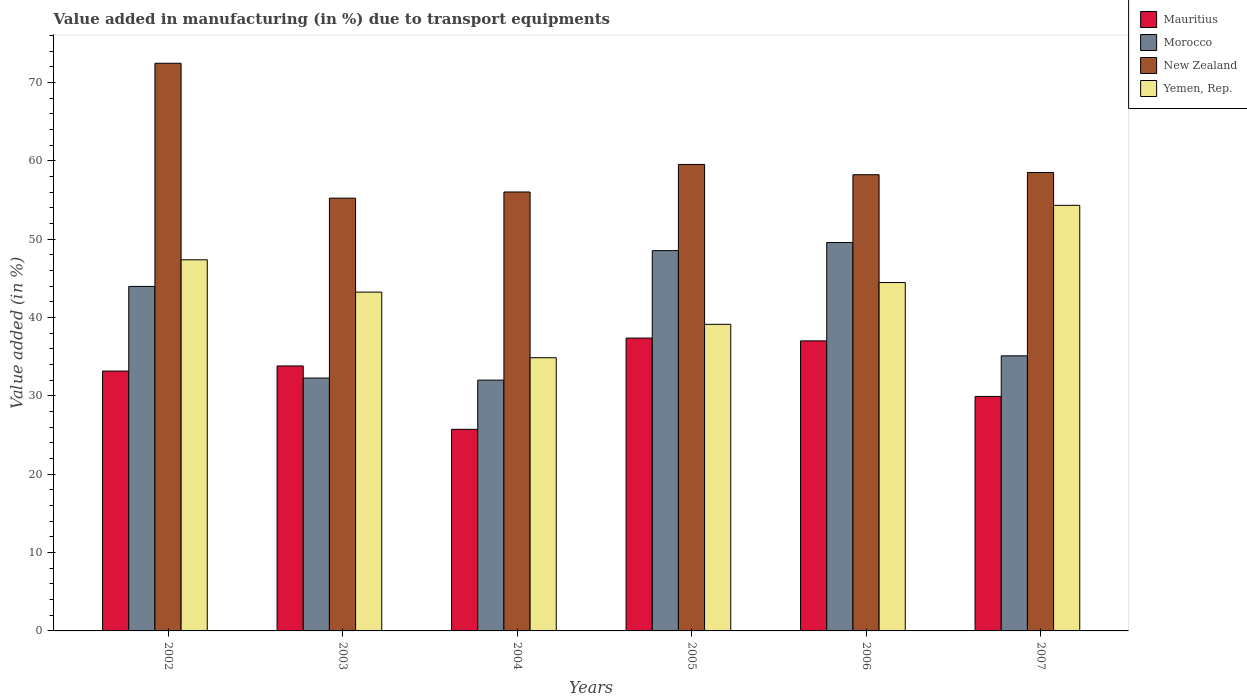How many groups of bars are there?
Your answer should be compact. 6. Are the number of bars on each tick of the X-axis equal?
Your answer should be compact. Yes. How many bars are there on the 4th tick from the left?
Keep it short and to the point. 4. In how many cases, is the number of bars for a given year not equal to the number of legend labels?
Provide a succinct answer. 0. What is the percentage of value added in manufacturing due to transport equipments in Yemen, Rep. in 2002?
Keep it short and to the point. 47.36. Across all years, what is the maximum percentage of value added in manufacturing due to transport equipments in New Zealand?
Keep it short and to the point. 72.45. Across all years, what is the minimum percentage of value added in manufacturing due to transport equipments in Morocco?
Keep it short and to the point. 32.01. In which year was the percentage of value added in manufacturing due to transport equipments in Mauritius maximum?
Provide a succinct answer. 2005. In which year was the percentage of value added in manufacturing due to transport equipments in New Zealand minimum?
Ensure brevity in your answer.  2003. What is the total percentage of value added in manufacturing due to transport equipments in New Zealand in the graph?
Provide a short and direct response. 359.95. What is the difference between the percentage of value added in manufacturing due to transport equipments in Yemen, Rep. in 2003 and that in 2004?
Offer a very short reply. 8.37. What is the difference between the percentage of value added in manufacturing due to transport equipments in Morocco in 2005 and the percentage of value added in manufacturing due to transport equipments in Yemen, Rep. in 2006?
Give a very brief answer. 4.07. What is the average percentage of value added in manufacturing due to transport equipments in Morocco per year?
Keep it short and to the point. 40.24. In the year 2006, what is the difference between the percentage of value added in manufacturing due to transport equipments in Mauritius and percentage of value added in manufacturing due to transport equipments in Morocco?
Your answer should be very brief. -12.55. In how many years, is the percentage of value added in manufacturing due to transport equipments in Yemen, Rep. greater than 6 %?
Your answer should be very brief. 6. What is the ratio of the percentage of value added in manufacturing due to transport equipments in New Zealand in 2003 to that in 2006?
Offer a terse response. 0.95. Is the difference between the percentage of value added in manufacturing due to transport equipments in Mauritius in 2002 and 2004 greater than the difference between the percentage of value added in manufacturing due to transport equipments in Morocco in 2002 and 2004?
Ensure brevity in your answer.  No. What is the difference between the highest and the second highest percentage of value added in manufacturing due to transport equipments in Mauritius?
Give a very brief answer. 0.36. What is the difference between the highest and the lowest percentage of value added in manufacturing due to transport equipments in Mauritius?
Offer a very short reply. 11.64. Is the sum of the percentage of value added in manufacturing due to transport equipments in Morocco in 2002 and 2006 greater than the maximum percentage of value added in manufacturing due to transport equipments in Mauritius across all years?
Provide a succinct answer. Yes. Is it the case that in every year, the sum of the percentage of value added in manufacturing due to transport equipments in Morocco and percentage of value added in manufacturing due to transport equipments in Mauritius is greater than the sum of percentage of value added in manufacturing due to transport equipments in Yemen, Rep. and percentage of value added in manufacturing due to transport equipments in New Zealand?
Provide a succinct answer. No. What does the 1st bar from the left in 2003 represents?
Offer a very short reply. Mauritius. What does the 3rd bar from the right in 2007 represents?
Give a very brief answer. Morocco. How many bars are there?
Your answer should be compact. 24. What is the difference between two consecutive major ticks on the Y-axis?
Provide a short and direct response. 10. Are the values on the major ticks of Y-axis written in scientific E-notation?
Keep it short and to the point. No. Does the graph contain grids?
Provide a short and direct response. No. Where does the legend appear in the graph?
Give a very brief answer. Top right. How many legend labels are there?
Keep it short and to the point. 4. What is the title of the graph?
Ensure brevity in your answer.  Value added in manufacturing (in %) due to transport equipments. Does "American Samoa" appear as one of the legend labels in the graph?
Keep it short and to the point. No. What is the label or title of the Y-axis?
Offer a terse response. Value added (in %). What is the Value added (in %) of Mauritius in 2002?
Give a very brief answer. 33.16. What is the Value added (in %) of Morocco in 2002?
Your answer should be compact. 43.97. What is the Value added (in %) of New Zealand in 2002?
Provide a short and direct response. 72.45. What is the Value added (in %) in Yemen, Rep. in 2002?
Make the answer very short. 47.36. What is the Value added (in %) in Mauritius in 2003?
Offer a very short reply. 33.81. What is the Value added (in %) in Morocco in 2003?
Offer a terse response. 32.27. What is the Value added (in %) of New Zealand in 2003?
Provide a succinct answer. 55.23. What is the Value added (in %) in Yemen, Rep. in 2003?
Make the answer very short. 43.24. What is the Value added (in %) of Mauritius in 2004?
Give a very brief answer. 25.73. What is the Value added (in %) of Morocco in 2004?
Provide a succinct answer. 32.01. What is the Value added (in %) in New Zealand in 2004?
Ensure brevity in your answer.  56.02. What is the Value added (in %) in Yemen, Rep. in 2004?
Keep it short and to the point. 34.86. What is the Value added (in %) of Mauritius in 2005?
Make the answer very short. 37.37. What is the Value added (in %) of Morocco in 2005?
Provide a short and direct response. 48.53. What is the Value added (in %) in New Zealand in 2005?
Your response must be concise. 59.53. What is the Value added (in %) of Yemen, Rep. in 2005?
Your answer should be very brief. 39.13. What is the Value added (in %) in Mauritius in 2006?
Your answer should be very brief. 37.02. What is the Value added (in %) of Morocco in 2006?
Provide a succinct answer. 49.57. What is the Value added (in %) of New Zealand in 2006?
Your response must be concise. 58.22. What is the Value added (in %) of Yemen, Rep. in 2006?
Your response must be concise. 44.46. What is the Value added (in %) of Mauritius in 2007?
Provide a succinct answer. 29.93. What is the Value added (in %) of Morocco in 2007?
Make the answer very short. 35.11. What is the Value added (in %) of New Zealand in 2007?
Keep it short and to the point. 58.5. What is the Value added (in %) of Yemen, Rep. in 2007?
Make the answer very short. 54.32. Across all years, what is the maximum Value added (in %) of Mauritius?
Offer a very short reply. 37.37. Across all years, what is the maximum Value added (in %) of Morocco?
Provide a succinct answer. 49.57. Across all years, what is the maximum Value added (in %) of New Zealand?
Offer a terse response. 72.45. Across all years, what is the maximum Value added (in %) of Yemen, Rep.?
Make the answer very short. 54.32. Across all years, what is the minimum Value added (in %) in Mauritius?
Provide a short and direct response. 25.73. Across all years, what is the minimum Value added (in %) in Morocco?
Make the answer very short. 32.01. Across all years, what is the minimum Value added (in %) in New Zealand?
Ensure brevity in your answer.  55.23. Across all years, what is the minimum Value added (in %) in Yemen, Rep.?
Provide a short and direct response. 34.86. What is the total Value added (in %) in Mauritius in the graph?
Give a very brief answer. 197.02. What is the total Value added (in %) in Morocco in the graph?
Ensure brevity in your answer.  241.45. What is the total Value added (in %) of New Zealand in the graph?
Make the answer very short. 359.95. What is the total Value added (in %) in Yemen, Rep. in the graph?
Your answer should be very brief. 263.37. What is the difference between the Value added (in %) of Mauritius in 2002 and that in 2003?
Provide a succinct answer. -0.65. What is the difference between the Value added (in %) in Morocco in 2002 and that in 2003?
Make the answer very short. 11.7. What is the difference between the Value added (in %) of New Zealand in 2002 and that in 2003?
Your answer should be compact. 17.21. What is the difference between the Value added (in %) of Yemen, Rep. in 2002 and that in 2003?
Ensure brevity in your answer.  4.12. What is the difference between the Value added (in %) in Mauritius in 2002 and that in 2004?
Give a very brief answer. 7.43. What is the difference between the Value added (in %) in Morocco in 2002 and that in 2004?
Your answer should be compact. 11.96. What is the difference between the Value added (in %) in New Zealand in 2002 and that in 2004?
Offer a very short reply. 16.43. What is the difference between the Value added (in %) of Yemen, Rep. in 2002 and that in 2004?
Ensure brevity in your answer.  12.5. What is the difference between the Value added (in %) of Mauritius in 2002 and that in 2005?
Your answer should be very brief. -4.21. What is the difference between the Value added (in %) in Morocco in 2002 and that in 2005?
Offer a very short reply. -4.57. What is the difference between the Value added (in %) in New Zealand in 2002 and that in 2005?
Ensure brevity in your answer.  12.91. What is the difference between the Value added (in %) in Yemen, Rep. in 2002 and that in 2005?
Offer a very short reply. 8.24. What is the difference between the Value added (in %) of Mauritius in 2002 and that in 2006?
Offer a terse response. -3.85. What is the difference between the Value added (in %) in Morocco in 2002 and that in 2006?
Offer a very short reply. -5.6. What is the difference between the Value added (in %) of New Zealand in 2002 and that in 2006?
Offer a terse response. 14.22. What is the difference between the Value added (in %) of Yemen, Rep. in 2002 and that in 2006?
Your response must be concise. 2.9. What is the difference between the Value added (in %) in Mauritius in 2002 and that in 2007?
Provide a succinct answer. 3.24. What is the difference between the Value added (in %) of Morocco in 2002 and that in 2007?
Your answer should be very brief. 8.86. What is the difference between the Value added (in %) of New Zealand in 2002 and that in 2007?
Offer a very short reply. 13.94. What is the difference between the Value added (in %) of Yemen, Rep. in 2002 and that in 2007?
Offer a terse response. -6.95. What is the difference between the Value added (in %) in Mauritius in 2003 and that in 2004?
Provide a succinct answer. 8.09. What is the difference between the Value added (in %) of Morocco in 2003 and that in 2004?
Keep it short and to the point. 0.26. What is the difference between the Value added (in %) in New Zealand in 2003 and that in 2004?
Make the answer very short. -0.79. What is the difference between the Value added (in %) in Yemen, Rep. in 2003 and that in 2004?
Your response must be concise. 8.37. What is the difference between the Value added (in %) in Mauritius in 2003 and that in 2005?
Your answer should be compact. -3.56. What is the difference between the Value added (in %) in Morocco in 2003 and that in 2005?
Provide a succinct answer. -16.26. What is the difference between the Value added (in %) of New Zealand in 2003 and that in 2005?
Make the answer very short. -4.3. What is the difference between the Value added (in %) in Yemen, Rep. in 2003 and that in 2005?
Ensure brevity in your answer.  4.11. What is the difference between the Value added (in %) in Mauritius in 2003 and that in 2006?
Provide a succinct answer. -3.2. What is the difference between the Value added (in %) of Morocco in 2003 and that in 2006?
Provide a succinct answer. -17.29. What is the difference between the Value added (in %) of New Zealand in 2003 and that in 2006?
Your response must be concise. -2.99. What is the difference between the Value added (in %) of Yemen, Rep. in 2003 and that in 2006?
Offer a terse response. -1.22. What is the difference between the Value added (in %) in Mauritius in 2003 and that in 2007?
Offer a terse response. 3.89. What is the difference between the Value added (in %) in Morocco in 2003 and that in 2007?
Your response must be concise. -2.83. What is the difference between the Value added (in %) of New Zealand in 2003 and that in 2007?
Make the answer very short. -3.27. What is the difference between the Value added (in %) of Yemen, Rep. in 2003 and that in 2007?
Make the answer very short. -11.08. What is the difference between the Value added (in %) of Mauritius in 2004 and that in 2005?
Provide a short and direct response. -11.64. What is the difference between the Value added (in %) of Morocco in 2004 and that in 2005?
Give a very brief answer. -16.52. What is the difference between the Value added (in %) in New Zealand in 2004 and that in 2005?
Provide a succinct answer. -3.52. What is the difference between the Value added (in %) of Yemen, Rep. in 2004 and that in 2005?
Your answer should be compact. -4.26. What is the difference between the Value added (in %) in Mauritius in 2004 and that in 2006?
Your response must be concise. -11.29. What is the difference between the Value added (in %) in Morocco in 2004 and that in 2006?
Provide a succinct answer. -17.56. What is the difference between the Value added (in %) in New Zealand in 2004 and that in 2006?
Give a very brief answer. -2.2. What is the difference between the Value added (in %) of Yemen, Rep. in 2004 and that in 2006?
Offer a very short reply. -9.6. What is the difference between the Value added (in %) of Mauritius in 2004 and that in 2007?
Ensure brevity in your answer.  -4.2. What is the difference between the Value added (in %) in Morocco in 2004 and that in 2007?
Your response must be concise. -3.1. What is the difference between the Value added (in %) in New Zealand in 2004 and that in 2007?
Give a very brief answer. -2.49. What is the difference between the Value added (in %) of Yemen, Rep. in 2004 and that in 2007?
Provide a short and direct response. -19.45. What is the difference between the Value added (in %) of Mauritius in 2005 and that in 2006?
Your response must be concise. 0.36. What is the difference between the Value added (in %) in Morocco in 2005 and that in 2006?
Your response must be concise. -1.03. What is the difference between the Value added (in %) in New Zealand in 2005 and that in 2006?
Ensure brevity in your answer.  1.31. What is the difference between the Value added (in %) of Yemen, Rep. in 2005 and that in 2006?
Give a very brief answer. -5.33. What is the difference between the Value added (in %) in Mauritius in 2005 and that in 2007?
Give a very brief answer. 7.44. What is the difference between the Value added (in %) of Morocco in 2005 and that in 2007?
Make the answer very short. 13.43. What is the difference between the Value added (in %) of New Zealand in 2005 and that in 2007?
Keep it short and to the point. 1.03. What is the difference between the Value added (in %) in Yemen, Rep. in 2005 and that in 2007?
Your answer should be compact. -15.19. What is the difference between the Value added (in %) in Mauritius in 2006 and that in 2007?
Make the answer very short. 7.09. What is the difference between the Value added (in %) in Morocco in 2006 and that in 2007?
Offer a very short reply. 14.46. What is the difference between the Value added (in %) of New Zealand in 2006 and that in 2007?
Provide a short and direct response. -0.28. What is the difference between the Value added (in %) in Yemen, Rep. in 2006 and that in 2007?
Offer a terse response. -9.86. What is the difference between the Value added (in %) in Mauritius in 2002 and the Value added (in %) in Morocco in 2003?
Give a very brief answer. 0.89. What is the difference between the Value added (in %) in Mauritius in 2002 and the Value added (in %) in New Zealand in 2003?
Your response must be concise. -22.07. What is the difference between the Value added (in %) of Mauritius in 2002 and the Value added (in %) of Yemen, Rep. in 2003?
Offer a very short reply. -10.07. What is the difference between the Value added (in %) in Morocco in 2002 and the Value added (in %) in New Zealand in 2003?
Offer a terse response. -11.26. What is the difference between the Value added (in %) in Morocco in 2002 and the Value added (in %) in Yemen, Rep. in 2003?
Keep it short and to the point. 0.73. What is the difference between the Value added (in %) of New Zealand in 2002 and the Value added (in %) of Yemen, Rep. in 2003?
Provide a short and direct response. 29.21. What is the difference between the Value added (in %) of Mauritius in 2002 and the Value added (in %) of Morocco in 2004?
Your response must be concise. 1.16. What is the difference between the Value added (in %) of Mauritius in 2002 and the Value added (in %) of New Zealand in 2004?
Your response must be concise. -22.85. What is the difference between the Value added (in %) in Mauritius in 2002 and the Value added (in %) in Yemen, Rep. in 2004?
Make the answer very short. -1.7. What is the difference between the Value added (in %) in Morocco in 2002 and the Value added (in %) in New Zealand in 2004?
Keep it short and to the point. -12.05. What is the difference between the Value added (in %) of Morocco in 2002 and the Value added (in %) of Yemen, Rep. in 2004?
Give a very brief answer. 9.1. What is the difference between the Value added (in %) in New Zealand in 2002 and the Value added (in %) in Yemen, Rep. in 2004?
Offer a terse response. 37.58. What is the difference between the Value added (in %) in Mauritius in 2002 and the Value added (in %) in Morocco in 2005?
Offer a very short reply. -15.37. What is the difference between the Value added (in %) of Mauritius in 2002 and the Value added (in %) of New Zealand in 2005?
Offer a terse response. -26.37. What is the difference between the Value added (in %) of Mauritius in 2002 and the Value added (in %) of Yemen, Rep. in 2005?
Your answer should be compact. -5.96. What is the difference between the Value added (in %) in Morocco in 2002 and the Value added (in %) in New Zealand in 2005?
Provide a short and direct response. -15.57. What is the difference between the Value added (in %) of Morocco in 2002 and the Value added (in %) of Yemen, Rep. in 2005?
Your response must be concise. 4.84. What is the difference between the Value added (in %) of New Zealand in 2002 and the Value added (in %) of Yemen, Rep. in 2005?
Keep it short and to the point. 33.32. What is the difference between the Value added (in %) of Mauritius in 2002 and the Value added (in %) of Morocco in 2006?
Give a very brief answer. -16.4. What is the difference between the Value added (in %) in Mauritius in 2002 and the Value added (in %) in New Zealand in 2006?
Ensure brevity in your answer.  -25.06. What is the difference between the Value added (in %) in Mauritius in 2002 and the Value added (in %) in Yemen, Rep. in 2006?
Make the answer very short. -11.3. What is the difference between the Value added (in %) of Morocco in 2002 and the Value added (in %) of New Zealand in 2006?
Ensure brevity in your answer.  -14.25. What is the difference between the Value added (in %) of Morocco in 2002 and the Value added (in %) of Yemen, Rep. in 2006?
Offer a terse response. -0.49. What is the difference between the Value added (in %) of New Zealand in 2002 and the Value added (in %) of Yemen, Rep. in 2006?
Make the answer very short. 27.98. What is the difference between the Value added (in %) in Mauritius in 2002 and the Value added (in %) in Morocco in 2007?
Your answer should be compact. -1.94. What is the difference between the Value added (in %) in Mauritius in 2002 and the Value added (in %) in New Zealand in 2007?
Offer a very short reply. -25.34. What is the difference between the Value added (in %) in Mauritius in 2002 and the Value added (in %) in Yemen, Rep. in 2007?
Provide a short and direct response. -21.15. What is the difference between the Value added (in %) in Morocco in 2002 and the Value added (in %) in New Zealand in 2007?
Offer a very short reply. -14.54. What is the difference between the Value added (in %) in Morocco in 2002 and the Value added (in %) in Yemen, Rep. in 2007?
Ensure brevity in your answer.  -10.35. What is the difference between the Value added (in %) in New Zealand in 2002 and the Value added (in %) in Yemen, Rep. in 2007?
Ensure brevity in your answer.  18.13. What is the difference between the Value added (in %) of Mauritius in 2003 and the Value added (in %) of Morocco in 2004?
Ensure brevity in your answer.  1.81. What is the difference between the Value added (in %) in Mauritius in 2003 and the Value added (in %) in New Zealand in 2004?
Offer a terse response. -22.2. What is the difference between the Value added (in %) of Mauritius in 2003 and the Value added (in %) of Yemen, Rep. in 2004?
Make the answer very short. -1.05. What is the difference between the Value added (in %) in Morocco in 2003 and the Value added (in %) in New Zealand in 2004?
Offer a very short reply. -23.75. What is the difference between the Value added (in %) in Morocco in 2003 and the Value added (in %) in Yemen, Rep. in 2004?
Your answer should be compact. -2.59. What is the difference between the Value added (in %) in New Zealand in 2003 and the Value added (in %) in Yemen, Rep. in 2004?
Your answer should be very brief. 20.37. What is the difference between the Value added (in %) in Mauritius in 2003 and the Value added (in %) in Morocco in 2005?
Your answer should be very brief. -14.72. What is the difference between the Value added (in %) of Mauritius in 2003 and the Value added (in %) of New Zealand in 2005?
Offer a terse response. -25.72. What is the difference between the Value added (in %) of Mauritius in 2003 and the Value added (in %) of Yemen, Rep. in 2005?
Your response must be concise. -5.31. What is the difference between the Value added (in %) of Morocco in 2003 and the Value added (in %) of New Zealand in 2005?
Ensure brevity in your answer.  -27.26. What is the difference between the Value added (in %) in Morocco in 2003 and the Value added (in %) in Yemen, Rep. in 2005?
Give a very brief answer. -6.86. What is the difference between the Value added (in %) in New Zealand in 2003 and the Value added (in %) in Yemen, Rep. in 2005?
Offer a very short reply. 16.1. What is the difference between the Value added (in %) of Mauritius in 2003 and the Value added (in %) of Morocco in 2006?
Offer a terse response. -15.75. What is the difference between the Value added (in %) of Mauritius in 2003 and the Value added (in %) of New Zealand in 2006?
Offer a very short reply. -24.41. What is the difference between the Value added (in %) in Mauritius in 2003 and the Value added (in %) in Yemen, Rep. in 2006?
Make the answer very short. -10.65. What is the difference between the Value added (in %) in Morocco in 2003 and the Value added (in %) in New Zealand in 2006?
Make the answer very short. -25.95. What is the difference between the Value added (in %) of Morocco in 2003 and the Value added (in %) of Yemen, Rep. in 2006?
Your answer should be compact. -12.19. What is the difference between the Value added (in %) of New Zealand in 2003 and the Value added (in %) of Yemen, Rep. in 2006?
Offer a terse response. 10.77. What is the difference between the Value added (in %) of Mauritius in 2003 and the Value added (in %) of Morocco in 2007?
Make the answer very short. -1.29. What is the difference between the Value added (in %) of Mauritius in 2003 and the Value added (in %) of New Zealand in 2007?
Make the answer very short. -24.69. What is the difference between the Value added (in %) in Mauritius in 2003 and the Value added (in %) in Yemen, Rep. in 2007?
Offer a terse response. -20.5. What is the difference between the Value added (in %) of Morocco in 2003 and the Value added (in %) of New Zealand in 2007?
Provide a succinct answer. -26.23. What is the difference between the Value added (in %) in Morocco in 2003 and the Value added (in %) in Yemen, Rep. in 2007?
Offer a very short reply. -22.04. What is the difference between the Value added (in %) in New Zealand in 2003 and the Value added (in %) in Yemen, Rep. in 2007?
Offer a very short reply. 0.92. What is the difference between the Value added (in %) of Mauritius in 2004 and the Value added (in %) of Morocco in 2005?
Ensure brevity in your answer.  -22.8. What is the difference between the Value added (in %) in Mauritius in 2004 and the Value added (in %) in New Zealand in 2005?
Ensure brevity in your answer.  -33.8. What is the difference between the Value added (in %) in Mauritius in 2004 and the Value added (in %) in Yemen, Rep. in 2005?
Make the answer very short. -13.4. What is the difference between the Value added (in %) in Morocco in 2004 and the Value added (in %) in New Zealand in 2005?
Offer a very short reply. -27.52. What is the difference between the Value added (in %) in Morocco in 2004 and the Value added (in %) in Yemen, Rep. in 2005?
Provide a succinct answer. -7.12. What is the difference between the Value added (in %) in New Zealand in 2004 and the Value added (in %) in Yemen, Rep. in 2005?
Your answer should be very brief. 16.89. What is the difference between the Value added (in %) in Mauritius in 2004 and the Value added (in %) in Morocco in 2006?
Make the answer very short. -23.84. What is the difference between the Value added (in %) of Mauritius in 2004 and the Value added (in %) of New Zealand in 2006?
Your answer should be very brief. -32.49. What is the difference between the Value added (in %) of Mauritius in 2004 and the Value added (in %) of Yemen, Rep. in 2006?
Make the answer very short. -18.73. What is the difference between the Value added (in %) of Morocco in 2004 and the Value added (in %) of New Zealand in 2006?
Provide a short and direct response. -26.21. What is the difference between the Value added (in %) in Morocco in 2004 and the Value added (in %) in Yemen, Rep. in 2006?
Provide a succinct answer. -12.45. What is the difference between the Value added (in %) in New Zealand in 2004 and the Value added (in %) in Yemen, Rep. in 2006?
Your answer should be very brief. 11.56. What is the difference between the Value added (in %) of Mauritius in 2004 and the Value added (in %) of Morocco in 2007?
Provide a short and direct response. -9.38. What is the difference between the Value added (in %) of Mauritius in 2004 and the Value added (in %) of New Zealand in 2007?
Offer a very short reply. -32.77. What is the difference between the Value added (in %) in Mauritius in 2004 and the Value added (in %) in Yemen, Rep. in 2007?
Provide a succinct answer. -28.59. What is the difference between the Value added (in %) of Morocco in 2004 and the Value added (in %) of New Zealand in 2007?
Your response must be concise. -26.5. What is the difference between the Value added (in %) in Morocco in 2004 and the Value added (in %) in Yemen, Rep. in 2007?
Provide a short and direct response. -22.31. What is the difference between the Value added (in %) in New Zealand in 2004 and the Value added (in %) in Yemen, Rep. in 2007?
Your answer should be very brief. 1.7. What is the difference between the Value added (in %) in Mauritius in 2005 and the Value added (in %) in Morocco in 2006?
Offer a very short reply. -12.19. What is the difference between the Value added (in %) of Mauritius in 2005 and the Value added (in %) of New Zealand in 2006?
Offer a very short reply. -20.85. What is the difference between the Value added (in %) in Mauritius in 2005 and the Value added (in %) in Yemen, Rep. in 2006?
Your answer should be very brief. -7.09. What is the difference between the Value added (in %) of Morocco in 2005 and the Value added (in %) of New Zealand in 2006?
Your answer should be very brief. -9.69. What is the difference between the Value added (in %) in Morocco in 2005 and the Value added (in %) in Yemen, Rep. in 2006?
Your response must be concise. 4.07. What is the difference between the Value added (in %) of New Zealand in 2005 and the Value added (in %) of Yemen, Rep. in 2006?
Your answer should be very brief. 15.07. What is the difference between the Value added (in %) of Mauritius in 2005 and the Value added (in %) of Morocco in 2007?
Give a very brief answer. 2.27. What is the difference between the Value added (in %) in Mauritius in 2005 and the Value added (in %) in New Zealand in 2007?
Offer a terse response. -21.13. What is the difference between the Value added (in %) in Mauritius in 2005 and the Value added (in %) in Yemen, Rep. in 2007?
Ensure brevity in your answer.  -16.94. What is the difference between the Value added (in %) of Morocco in 2005 and the Value added (in %) of New Zealand in 2007?
Provide a succinct answer. -9.97. What is the difference between the Value added (in %) in Morocco in 2005 and the Value added (in %) in Yemen, Rep. in 2007?
Your answer should be very brief. -5.78. What is the difference between the Value added (in %) of New Zealand in 2005 and the Value added (in %) of Yemen, Rep. in 2007?
Provide a succinct answer. 5.22. What is the difference between the Value added (in %) of Mauritius in 2006 and the Value added (in %) of Morocco in 2007?
Your response must be concise. 1.91. What is the difference between the Value added (in %) of Mauritius in 2006 and the Value added (in %) of New Zealand in 2007?
Ensure brevity in your answer.  -21.49. What is the difference between the Value added (in %) in Mauritius in 2006 and the Value added (in %) in Yemen, Rep. in 2007?
Your response must be concise. -17.3. What is the difference between the Value added (in %) of Morocco in 2006 and the Value added (in %) of New Zealand in 2007?
Make the answer very short. -8.94. What is the difference between the Value added (in %) in Morocco in 2006 and the Value added (in %) in Yemen, Rep. in 2007?
Provide a short and direct response. -4.75. What is the difference between the Value added (in %) in New Zealand in 2006 and the Value added (in %) in Yemen, Rep. in 2007?
Provide a succinct answer. 3.91. What is the average Value added (in %) of Mauritius per year?
Make the answer very short. 32.84. What is the average Value added (in %) in Morocco per year?
Ensure brevity in your answer.  40.24. What is the average Value added (in %) of New Zealand per year?
Give a very brief answer. 59.99. What is the average Value added (in %) in Yemen, Rep. per year?
Make the answer very short. 43.9. In the year 2002, what is the difference between the Value added (in %) in Mauritius and Value added (in %) in Morocco?
Make the answer very short. -10.8. In the year 2002, what is the difference between the Value added (in %) in Mauritius and Value added (in %) in New Zealand?
Offer a terse response. -39.28. In the year 2002, what is the difference between the Value added (in %) in Mauritius and Value added (in %) in Yemen, Rep.?
Your answer should be very brief. -14.2. In the year 2002, what is the difference between the Value added (in %) in Morocco and Value added (in %) in New Zealand?
Provide a short and direct response. -28.48. In the year 2002, what is the difference between the Value added (in %) of Morocco and Value added (in %) of Yemen, Rep.?
Your answer should be compact. -3.4. In the year 2002, what is the difference between the Value added (in %) in New Zealand and Value added (in %) in Yemen, Rep.?
Ensure brevity in your answer.  25.08. In the year 2003, what is the difference between the Value added (in %) of Mauritius and Value added (in %) of Morocco?
Give a very brief answer. 1.54. In the year 2003, what is the difference between the Value added (in %) in Mauritius and Value added (in %) in New Zealand?
Your answer should be very brief. -21.42. In the year 2003, what is the difference between the Value added (in %) in Mauritius and Value added (in %) in Yemen, Rep.?
Make the answer very short. -9.42. In the year 2003, what is the difference between the Value added (in %) of Morocco and Value added (in %) of New Zealand?
Give a very brief answer. -22.96. In the year 2003, what is the difference between the Value added (in %) of Morocco and Value added (in %) of Yemen, Rep.?
Keep it short and to the point. -10.97. In the year 2003, what is the difference between the Value added (in %) in New Zealand and Value added (in %) in Yemen, Rep.?
Offer a very short reply. 11.99. In the year 2004, what is the difference between the Value added (in %) in Mauritius and Value added (in %) in Morocco?
Your answer should be very brief. -6.28. In the year 2004, what is the difference between the Value added (in %) in Mauritius and Value added (in %) in New Zealand?
Keep it short and to the point. -30.29. In the year 2004, what is the difference between the Value added (in %) in Mauritius and Value added (in %) in Yemen, Rep.?
Offer a very short reply. -9.14. In the year 2004, what is the difference between the Value added (in %) in Morocco and Value added (in %) in New Zealand?
Make the answer very short. -24.01. In the year 2004, what is the difference between the Value added (in %) in Morocco and Value added (in %) in Yemen, Rep.?
Offer a terse response. -2.86. In the year 2004, what is the difference between the Value added (in %) in New Zealand and Value added (in %) in Yemen, Rep.?
Your answer should be compact. 21.15. In the year 2005, what is the difference between the Value added (in %) of Mauritius and Value added (in %) of Morocco?
Provide a succinct answer. -11.16. In the year 2005, what is the difference between the Value added (in %) in Mauritius and Value added (in %) in New Zealand?
Make the answer very short. -22.16. In the year 2005, what is the difference between the Value added (in %) of Mauritius and Value added (in %) of Yemen, Rep.?
Offer a terse response. -1.76. In the year 2005, what is the difference between the Value added (in %) of Morocco and Value added (in %) of New Zealand?
Make the answer very short. -11. In the year 2005, what is the difference between the Value added (in %) in Morocco and Value added (in %) in Yemen, Rep.?
Make the answer very short. 9.4. In the year 2005, what is the difference between the Value added (in %) in New Zealand and Value added (in %) in Yemen, Rep.?
Your response must be concise. 20.4. In the year 2006, what is the difference between the Value added (in %) in Mauritius and Value added (in %) in Morocco?
Your answer should be compact. -12.55. In the year 2006, what is the difference between the Value added (in %) of Mauritius and Value added (in %) of New Zealand?
Make the answer very short. -21.2. In the year 2006, what is the difference between the Value added (in %) in Mauritius and Value added (in %) in Yemen, Rep.?
Provide a succinct answer. -7.44. In the year 2006, what is the difference between the Value added (in %) of Morocco and Value added (in %) of New Zealand?
Keep it short and to the point. -8.65. In the year 2006, what is the difference between the Value added (in %) in Morocco and Value added (in %) in Yemen, Rep.?
Provide a short and direct response. 5.11. In the year 2006, what is the difference between the Value added (in %) of New Zealand and Value added (in %) of Yemen, Rep.?
Offer a very short reply. 13.76. In the year 2007, what is the difference between the Value added (in %) of Mauritius and Value added (in %) of Morocco?
Offer a very short reply. -5.18. In the year 2007, what is the difference between the Value added (in %) in Mauritius and Value added (in %) in New Zealand?
Your answer should be very brief. -28.58. In the year 2007, what is the difference between the Value added (in %) in Mauritius and Value added (in %) in Yemen, Rep.?
Ensure brevity in your answer.  -24.39. In the year 2007, what is the difference between the Value added (in %) in Morocco and Value added (in %) in New Zealand?
Provide a succinct answer. -23.4. In the year 2007, what is the difference between the Value added (in %) in Morocco and Value added (in %) in Yemen, Rep.?
Keep it short and to the point. -19.21. In the year 2007, what is the difference between the Value added (in %) in New Zealand and Value added (in %) in Yemen, Rep.?
Your answer should be very brief. 4.19. What is the ratio of the Value added (in %) of Mauritius in 2002 to that in 2003?
Your answer should be compact. 0.98. What is the ratio of the Value added (in %) in Morocco in 2002 to that in 2003?
Provide a short and direct response. 1.36. What is the ratio of the Value added (in %) of New Zealand in 2002 to that in 2003?
Offer a terse response. 1.31. What is the ratio of the Value added (in %) in Yemen, Rep. in 2002 to that in 2003?
Give a very brief answer. 1.1. What is the ratio of the Value added (in %) of Mauritius in 2002 to that in 2004?
Make the answer very short. 1.29. What is the ratio of the Value added (in %) in Morocco in 2002 to that in 2004?
Offer a terse response. 1.37. What is the ratio of the Value added (in %) in New Zealand in 2002 to that in 2004?
Provide a succinct answer. 1.29. What is the ratio of the Value added (in %) of Yemen, Rep. in 2002 to that in 2004?
Keep it short and to the point. 1.36. What is the ratio of the Value added (in %) in Mauritius in 2002 to that in 2005?
Make the answer very short. 0.89. What is the ratio of the Value added (in %) of Morocco in 2002 to that in 2005?
Your response must be concise. 0.91. What is the ratio of the Value added (in %) in New Zealand in 2002 to that in 2005?
Make the answer very short. 1.22. What is the ratio of the Value added (in %) of Yemen, Rep. in 2002 to that in 2005?
Provide a short and direct response. 1.21. What is the ratio of the Value added (in %) of Mauritius in 2002 to that in 2006?
Your response must be concise. 0.9. What is the ratio of the Value added (in %) in Morocco in 2002 to that in 2006?
Offer a very short reply. 0.89. What is the ratio of the Value added (in %) of New Zealand in 2002 to that in 2006?
Make the answer very short. 1.24. What is the ratio of the Value added (in %) in Yemen, Rep. in 2002 to that in 2006?
Provide a succinct answer. 1.07. What is the ratio of the Value added (in %) in Mauritius in 2002 to that in 2007?
Your answer should be compact. 1.11. What is the ratio of the Value added (in %) of Morocco in 2002 to that in 2007?
Offer a very short reply. 1.25. What is the ratio of the Value added (in %) of New Zealand in 2002 to that in 2007?
Your answer should be compact. 1.24. What is the ratio of the Value added (in %) of Yemen, Rep. in 2002 to that in 2007?
Your response must be concise. 0.87. What is the ratio of the Value added (in %) of Mauritius in 2003 to that in 2004?
Your response must be concise. 1.31. What is the ratio of the Value added (in %) of Morocco in 2003 to that in 2004?
Ensure brevity in your answer.  1.01. What is the ratio of the Value added (in %) of New Zealand in 2003 to that in 2004?
Provide a succinct answer. 0.99. What is the ratio of the Value added (in %) of Yemen, Rep. in 2003 to that in 2004?
Offer a very short reply. 1.24. What is the ratio of the Value added (in %) of Mauritius in 2003 to that in 2005?
Offer a very short reply. 0.9. What is the ratio of the Value added (in %) of Morocco in 2003 to that in 2005?
Give a very brief answer. 0.67. What is the ratio of the Value added (in %) in New Zealand in 2003 to that in 2005?
Your answer should be compact. 0.93. What is the ratio of the Value added (in %) in Yemen, Rep. in 2003 to that in 2005?
Give a very brief answer. 1.11. What is the ratio of the Value added (in %) in Mauritius in 2003 to that in 2006?
Keep it short and to the point. 0.91. What is the ratio of the Value added (in %) of Morocco in 2003 to that in 2006?
Your answer should be very brief. 0.65. What is the ratio of the Value added (in %) of New Zealand in 2003 to that in 2006?
Your answer should be very brief. 0.95. What is the ratio of the Value added (in %) of Yemen, Rep. in 2003 to that in 2006?
Ensure brevity in your answer.  0.97. What is the ratio of the Value added (in %) of Mauritius in 2003 to that in 2007?
Keep it short and to the point. 1.13. What is the ratio of the Value added (in %) in Morocco in 2003 to that in 2007?
Give a very brief answer. 0.92. What is the ratio of the Value added (in %) in New Zealand in 2003 to that in 2007?
Keep it short and to the point. 0.94. What is the ratio of the Value added (in %) in Yemen, Rep. in 2003 to that in 2007?
Your answer should be very brief. 0.8. What is the ratio of the Value added (in %) in Mauritius in 2004 to that in 2005?
Ensure brevity in your answer.  0.69. What is the ratio of the Value added (in %) of Morocco in 2004 to that in 2005?
Ensure brevity in your answer.  0.66. What is the ratio of the Value added (in %) in New Zealand in 2004 to that in 2005?
Your answer should be compact. 0.94. What is the ratio of the Value added (in %) of Yemen, Rep. in 2004 to that in 2005?
Ensure brevity in your answer.  0.89. What is the ratio of the Value added (in %) in Mauritius in 2004 to that in 2006?
Make the answer very short. 0.7. What is the ratio of the Value added (in %) in Morocco in 2004 to that in 2006?
Keep it short and to the point. 0.65. What is the ratio of the Value added (in %) of New Zealand in 2004 to that in 2006?
Offer a terse response. 0.96. What is the ratio of the Value added (in %) in Yemen, Rep. in 2004 to that in 2006?
Keep it short and to the point. 0.78. What is the ratio of the Value added (in %) in Mauritius in 2004 to that in 2007?
Give a very brief answer. 0.86. What is the ratio of the Value added (in %) of Morocco in 2004 to that in 2007?
Your answer should be very brief. 0.91. What is the ratio of the Value added (in %) in New Zealand in 2004 to that in 2007?
Make the answer very short. 0.96. What is the ratio of the Value added (in %) of Yemen, Rep. in 2004 to that in 2007?
Provide a short and direct response. 0.64. What is the ratio of the Value added (in %) of Mauritius in 2005 to that in 2006?
Your response must be concise. 1.01. What is the ratio of the Value added (in %) in Morocco in 2005 to that in 2006?
Your response must be concise. 0.98. What is the ratio of the Value added (in %) in New Zealand in 2005 to that in 2006?
Your answer should be compact. 1.02. What is the ratio of the Value added (in %) in Yemen, Rep. in 2005 to that in 2006?
Offer a terse response. 0.88. What is the ratio of the Value added (in %) in Mauritius in 2005 to that in 2007?
Provide a short and direct response. 1.25. What is the ratio of the Value added (in %) in Morocco in 2005 to that in 2007?
Keep it short and to the point. 1.38. What is the ratio of the Value added (in %) in New Zealand in 2005 to that in 2007?
Give a very brief answer. 1.02. What is the ratio of the Value added (in %) of Yemen, Rep. in 2005 to that in 2007?
Give a very brief answer. 0.72. What is the ratio of the Value added (in %) in Mauritius in 2006 to that in 2007?
Make the answer very short. 1.24. What is the ratio of the Value added (in %) of Morocco in 2006 to that in 2007?
Give a very brief answer. 1.41. What is the ratio of the Value added (in %) in Yemen, Rep. in 2006 to that in 2007?
Provide a succinct answer. 0.82. What is the difference between the highest and the second highest Value added (in %) of Mauritius?
Provide a succinct answer. 0.36. What is the difference between the highest and the second highest Value added (in %) in Morocco?
Give a very brief answer. 1.03. What is the difference between the highest and the second highest Value added (in %) in New Zealand?
Make the answer very short. 12.91. What is the difference between the highest and the second highest Value added (in %) of Yemen, Rep.?
Your answer should be very brief. 6.95. What is the difference between the highest and the lowest Value added (in %) of Mauritius?
Your answer should be very brief. 11.64. What is the difference between the highest and the lowest Value added (in %) in Morocco?
Provide a succinct answer. 17.56. What is the difference between the highest and the lowest Value added (in %) of New Zealand?
Offer a very short reply. 17.21. What is the difference between the highest and the lowest Value added (in %) of Yemen, Rep.?
Offer a terse response. 19.45. 